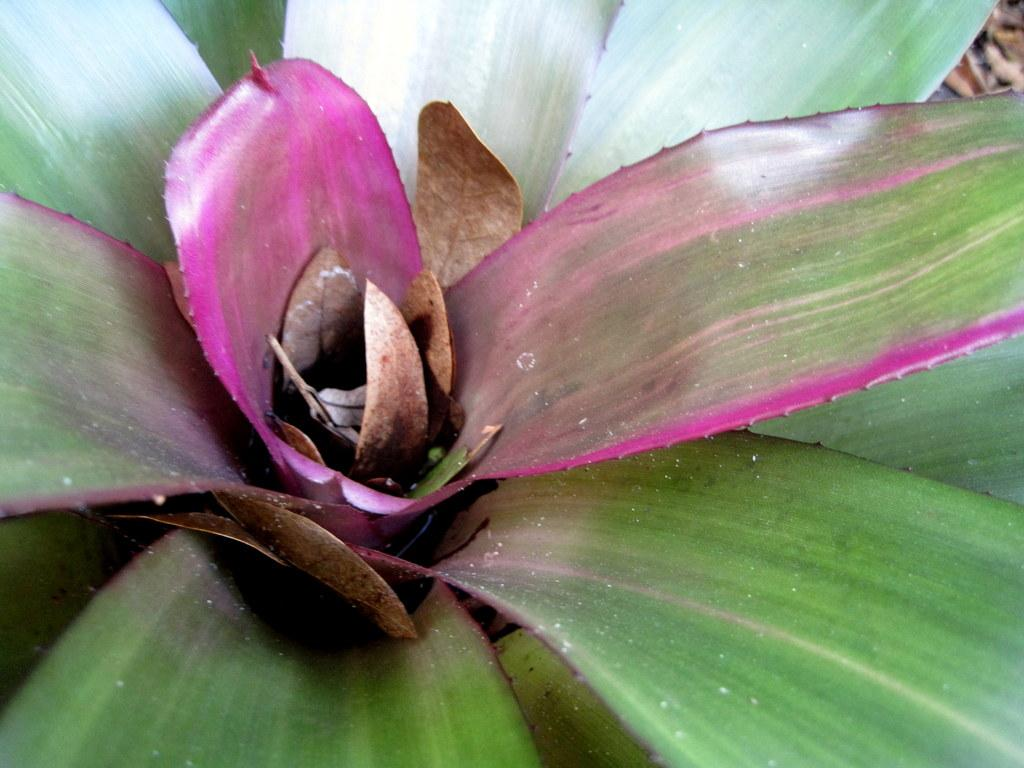What type of plant is in the image? There is an aloe vera plant in the image. Are there any leaves visible on the ground in the image? There might be leaves on the ground in the right corner of the image. How many laborers can be seen working on the aloe vera plant in the image? There are no laborers present in the image; it only shows the aloe vera plant and possibly some leaves on the ground. 